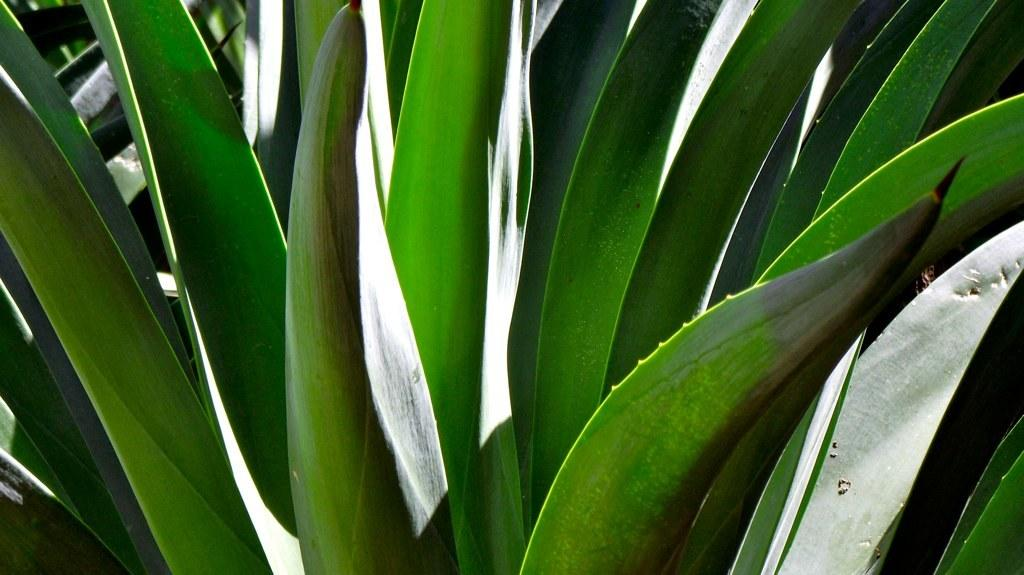What type of plants are in the image? There are agave plants in the image. What type of grain can be seen growing in the image? There is no grain present in the image; it features agave plants. What type of frame is surrounding the plants in the image? There is no frame surrounding the plants in the image; it is a natural scene with agave plants. What season is depicted in the image? The image does not depict a specific season, as agave plants can be found in various climates and seasons. 